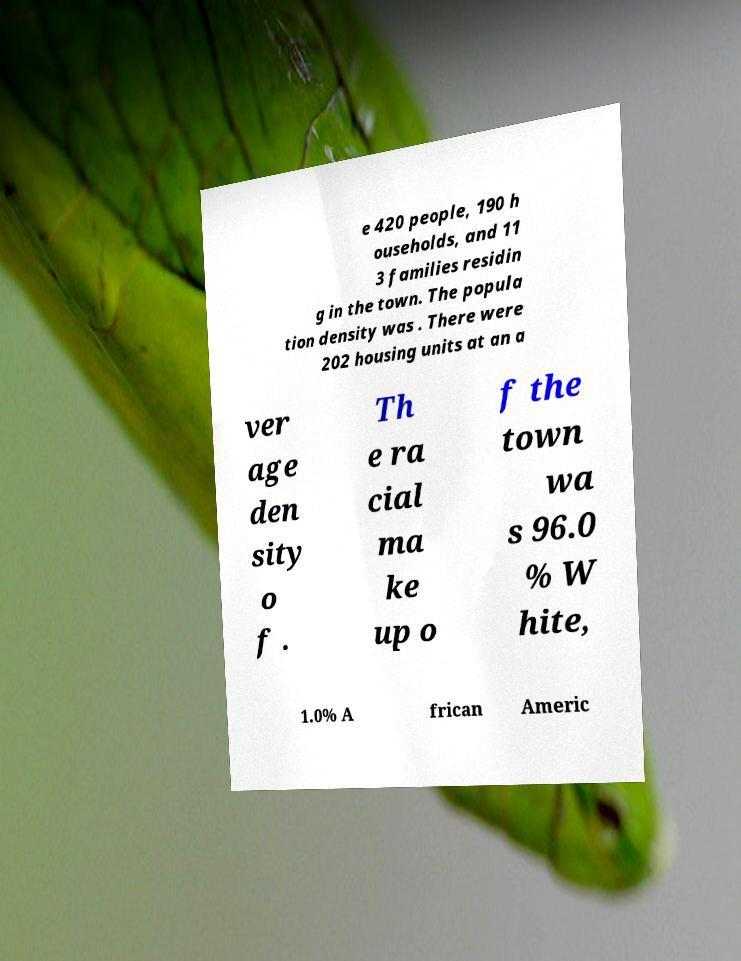I need the written content from this picture converted into text. Can you do that? e 420 people, 190 h ouseholds, and 11 3 families residin g in the town. The popula tion density was . There were 202 housing units at an a ver age den sity o f . Th e ra cial ma ke up o f the town wa s 96.0 % W hite, 1.0% A frican Americ 